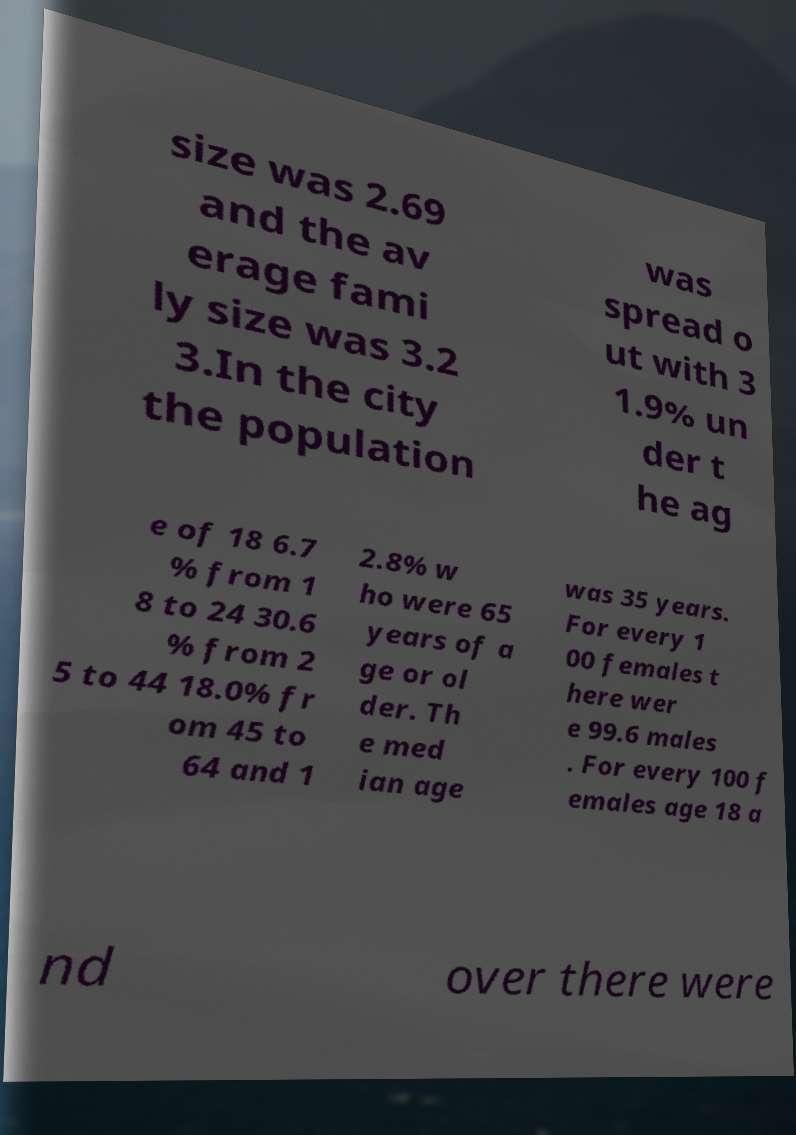I need the written content from this picture converted into text. Can you do that? size was 2.69 and the av erage fami ly size was 3.2 3.In the city the population was spread o ut with 3 1.9% un der t he ag e of 18 6.7 % from 1 8 to 24 30.6 % from 2 5 to 44 18.0% fr om 45 to 64 and 1 2.8% w ho were 65 years of a ge or ol der. Th e med ian age was 35 years. For every 1 00 females t here wer e 99.6 males . For every 100 f emales age 18 a nd over there were 